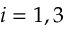<formula> <loc_0><loc_0><loc_500><loc_500>i = 1 , 3</formula> 